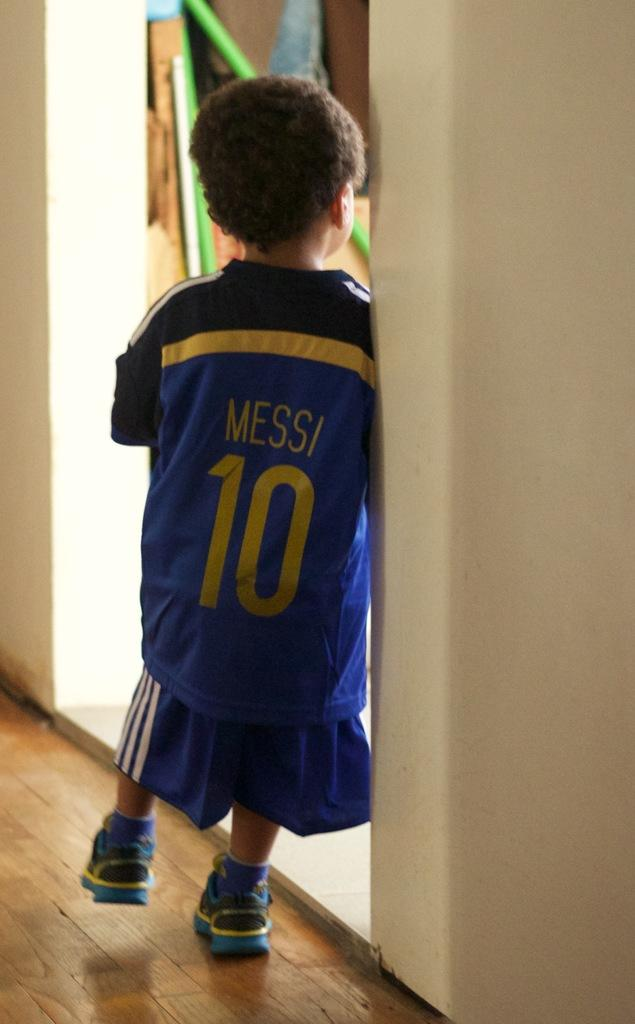<image>
Write a terse but informative summary of the picture. A young child is wearing a blue Jersey that says Messi 10 on it in yellow font. 